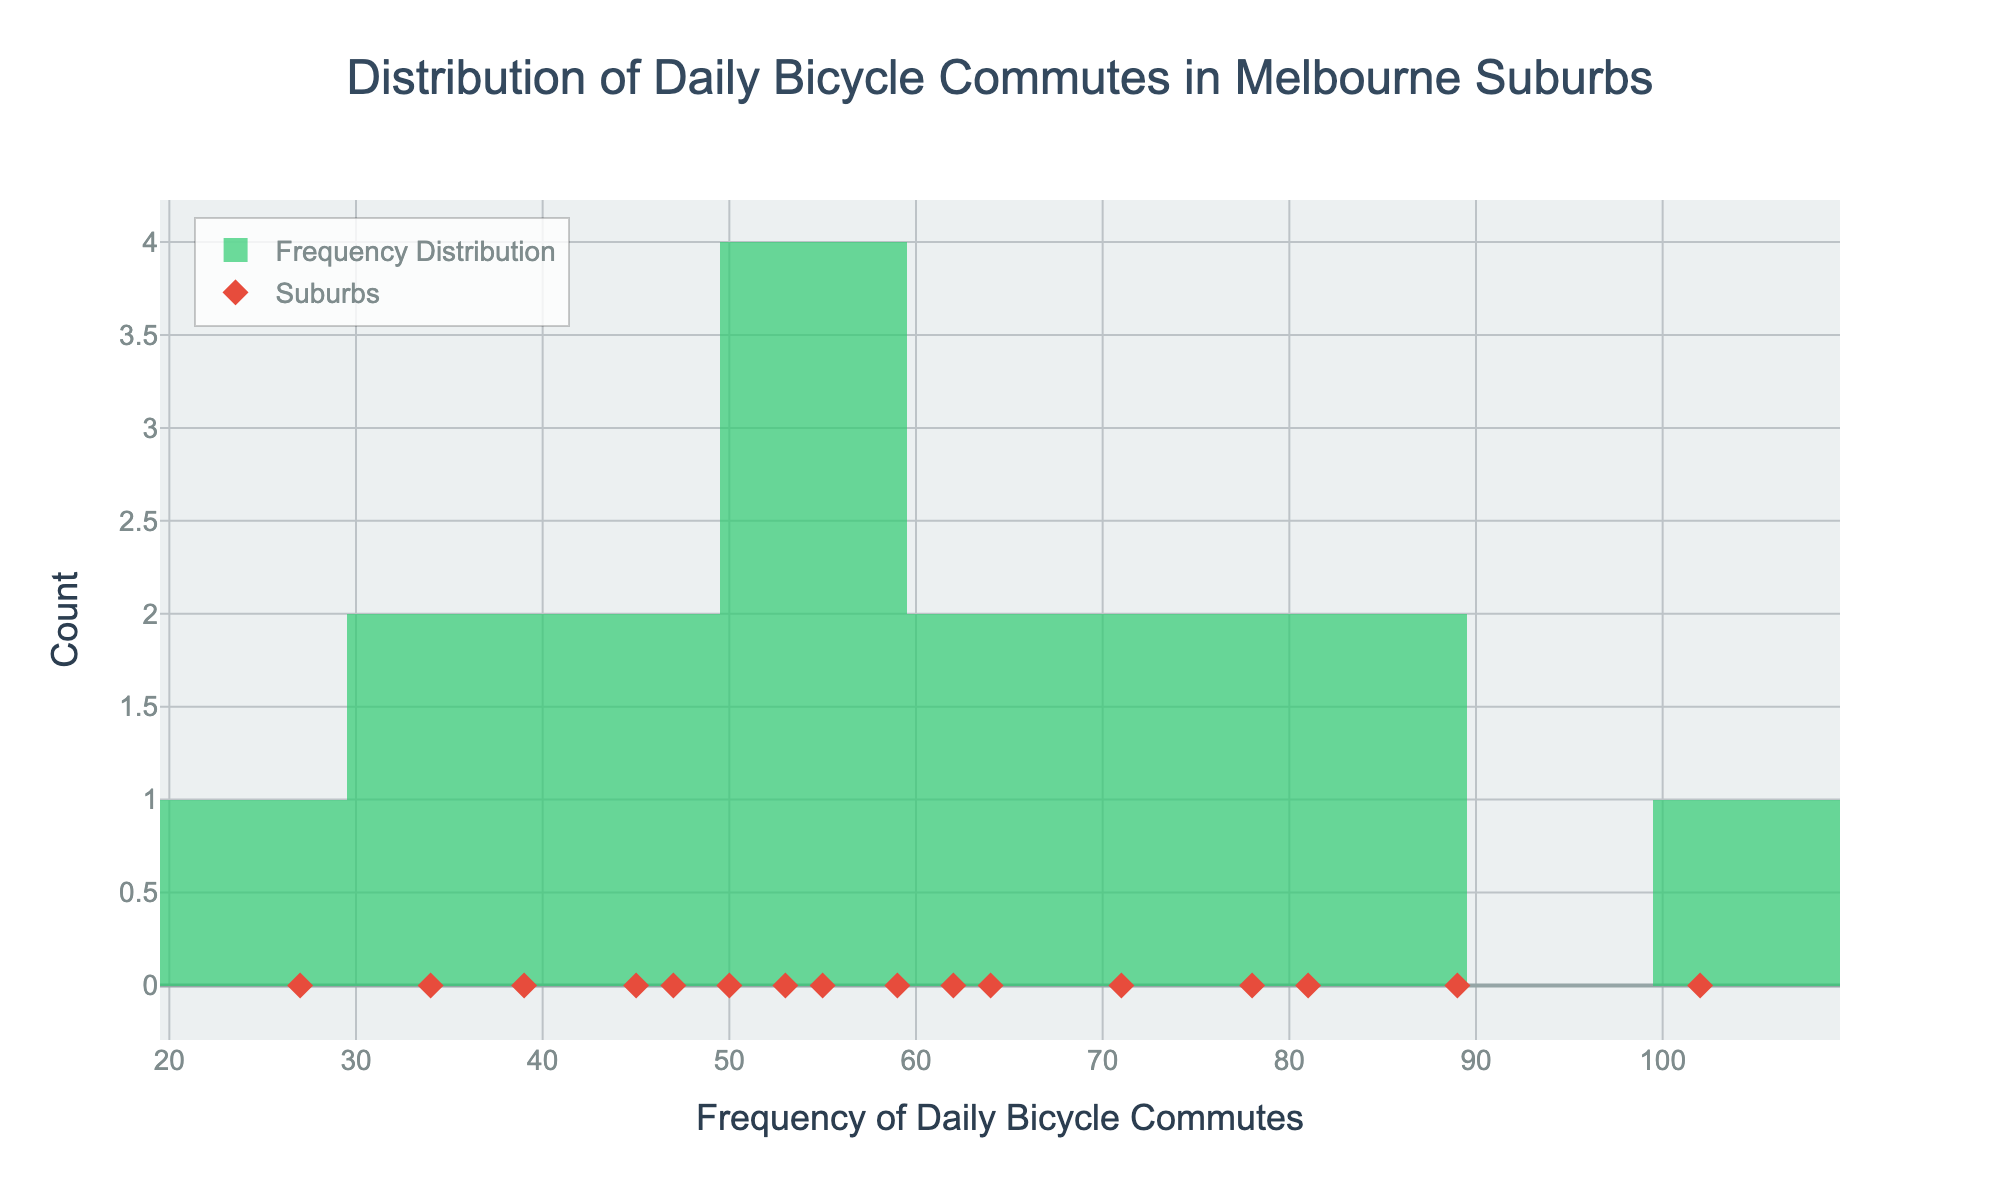What's the title of the plot? The title appears at the top center of the plot in a large font and is "Distribution of Daily Bicycle Commutes in Melbourne Suburbs"
Answer: Distribution of Daily Bicycle Commutes in Melbourne Suburbs What are the labels of the x-axis and y-axis? The labels are shown on the axes. The x-axis is labeled "Frequency of Daily Bicycle Commutes" and the y-axis is labeled "Count"
Answer: Frequency of Daily Bicycle Commutes; Count How many bins are used in the histogram? Count the number of bars in the histogram; the plot uses 10 bins.
Answer: 10 Which suburb has the highest frequency of daily bicycle commutes, and what is that frequency? The red diamond marker with the highest x-value corresponds to the frequency of 102 commutes, associated with Brunswick (as given in the hover info).
Answer: Brunswick; 102 What is the overall shape of the distribution? The histogram shows how data points are dispersed across the range of frequencies; it appears to be roughly symmetric and slightly right-skewed.
Answer: Roughly symmetric, slightly right-skewed Which suburb has the lowest frequency of daily bicycle commutes, and what is that frequency? The red diamond marker with the lowest x-value corresponds to the frequency of 27 commutes, associated with Docklands.
Answer: Docklands; 27 What is the range of the frequencies of daily bicycle commutes? The range can be calculated as the difference between the maximum and minimum values: 102 (Brunswick) - 27 (Docklands).
Answer: 75 How many suburbs have a frequency of daily bicycle commutes greater than 70? Count the red diamonds markers that appear above the x-value of 70: they correspond to Fitzroy, Brunswick, St Kilda, Richmond, and Thornbury.
Answer: 5 What is the median frequency of daily bicycle commutes? To find the median, list the frequencies in ascending order and locate the middle value (or the average of the two middle values for an even number of data points): Median is (59 + 62)/2 = 60.5.
Answer: 60.5 Is the frequency distribution more concentrated in the lower or higher range of frequencies? Observe where most of the histogram bars (and red diamonds) are densely placed; the distribution is more concentrated in the lower range (many values below 70).
Answer: Lower range 